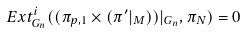<formula> <loc_0><loc_0><loc_500><loc_500>E x t ^ { i } _ { G _ { n } } ( ( \pi _ { p , 1 } \times ( \pi ^ { \prime } | _ { M } ) ) | _ { G _ { n } } , \pi _ { N } ) = 0</formula> 